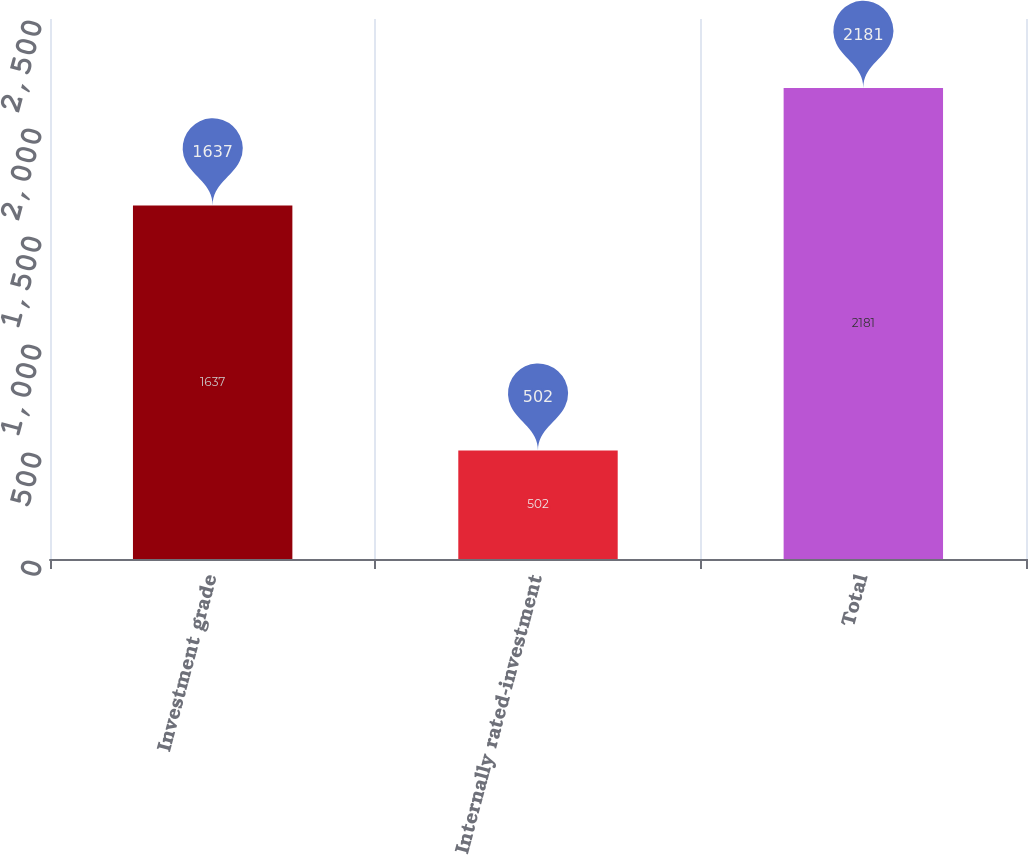Convert chart. <chart><loc_0><loc_0><loc_500><loc_500><bar_chart><fcel>Investment grade<fcel>Internally rated-investment<fcel>Total<nl><fcel>1637<fcel>502<fcel>2181<nl></chart> 